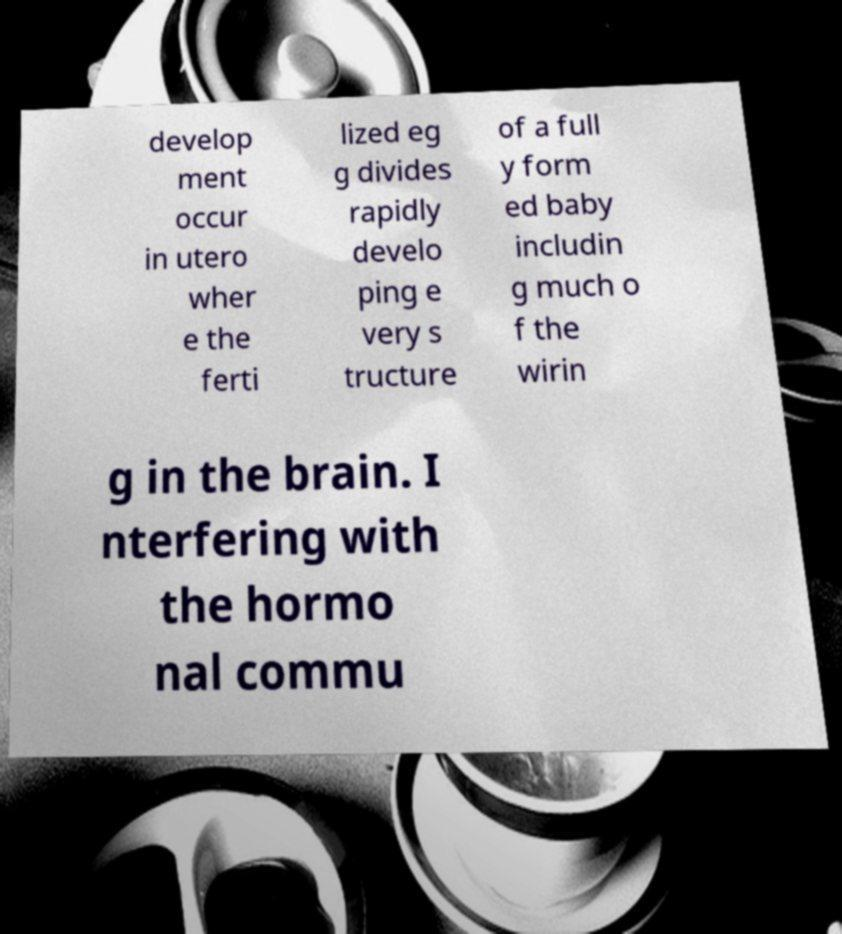There's text embedded in this image that I need extracted. Can you transcribe it verbatim? develop ment occur in utero wher e the ferti lized eg g divides rapidly develo ping e very s tructure of a full y form ed baby includin g much o f the wirin g in the brain. I nterfering with the hormo nal commu 